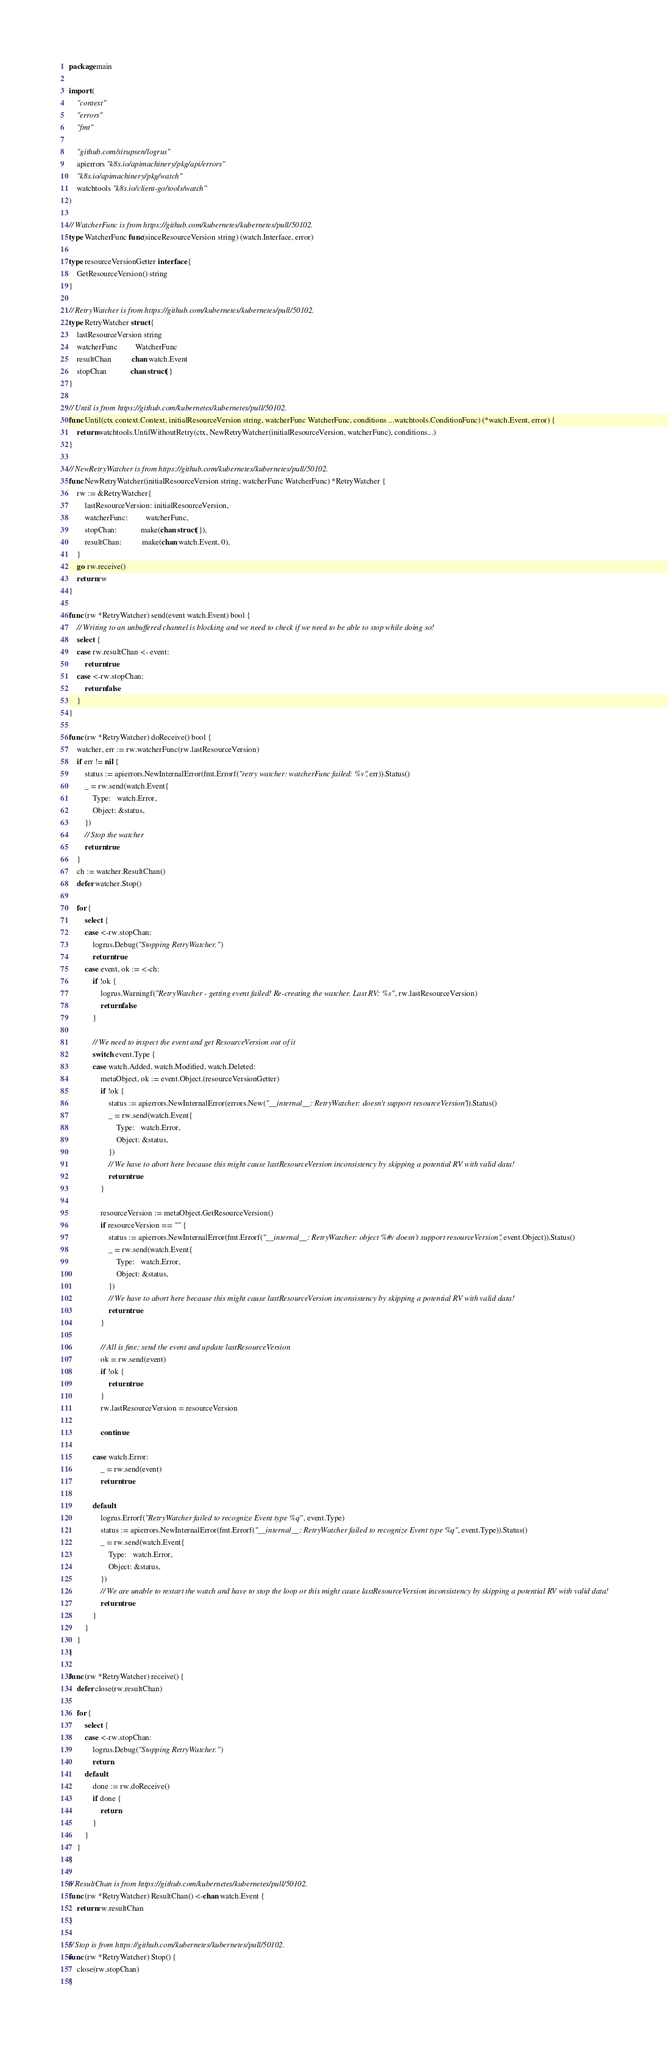Convert code to text. <code><loc_0><loc_0><loc_500><loc_500><_Go_>package main

import (
	"context"
	"errors"
	"fmt"

	"github.com/sirupsen/logrus"
	apierrors "k8s.io/apimachinery/pkg/api/errors"
	"k8s.io/apimachinery/pkg/watch"
	watchtools "k8s.io/client-go/tools/watch"
)

// WatcherFunc is from https://github.com/kubernetes/kubernetes/pull/50102.
type WatcherFunc func(sinceResourceVersion string) (watch.Interface, error)

type resourceVersionGetter interface {
	GetResourceVersion() string
}

// RetryWatcher is from https://github.com/kubernetes/kubernetes/pull/50102.
type RetryWatcher struct {
	lastResourceVersion string
	watcherFunc         WatcherFunc
	resultChan          chan watch.Event
	stopChan            chan struct{}
}

// Until is from https://github.com/kubernetes/kubernetes/pull/50102.
func Until(ctx context.Context, initialResourceVersion string, watcherFunc WatcherFunc, conditions ...watchtools.ConditionFunc) (*watch.Event, error) {
	return watchtools.UntilWithoutRetry(ctx, NewRetryWatcher(initialResourceVersion, watcherFunc), conditions...)
}

// NewRetryWatcher is from https://github.com/kubernetes/kubernetes/pull/50102.
func NewRetryWatcher(initialResourceVersion string, watcherFunc WatcherFunc) *RetryWatcher {
	rw := &RetryWatcher{
		lastResourceVersion: initialResourceVersion,
		watcherFunc:         watcherFunc,
		stopChan:            make(chan struct{}),
		resultChan:          make(chan watch.Event, 0),
	}
	go rw.receive()
	return rw
}

func (rw *RetryWatcher) send(event watch.Event) bool {
	// Writing to an unbuffered channel is blocking and we need to check if we need to be able to stop while doing so!
	select {
	case rw.resultChan <- event:
		return true
	case <-rw.stopChan:
		return false
	}
}

func (rw *RetryWatcher) doReceive() bool {
	watcher, err := rw.watcherFunc(rw.lastResourceVersion)
	if err != nil {
		status := apierrors.NewInternalError(fmt.Errorf("retry watcher: watcherFunc failed: %v", err)).Status()
		_ = rw.send(watch.Event{
			Type:   watch.Error,
			Object: &status,
		})
		// Stop the watcher
		return true
	}
	ch := watcher.ResultChan()
	defer watcher.Stop()

	for {
		select {
		case <-rw.stopChan:
			logrus.Debug("Stopping RetryWatcher.")
			return true
		case event, ok := <-ch:
			if !ok {
				logrus.Warningf("RetryWatcher - getting event failed! Re-creating the watcher. Last RV: %s", rw.lastResourceVersion)
				return false
			}

			// We need to inspect the event and get ResourceVersion out of it
			switch event.Type {
			case watch.Added, watch.Modified, watch.Deleted:
				metaObject, ok := event.Object.(resourceVersionGetter)
				if !ok {
					status := apierrors.NewInternalError(errors.New("__internal__: RetryWatcher: doesn't support resourceVersion")).Status()
					_ = rw.send(watch.Event{
						Type:   watch.Error,
						Object: &status,
					})
					// We have to abort here because this might cause lastResourceVersion inconsistency by skipping a potential RV with valid data!
					return true
				}

				resourceVersion := metaObject.GetResourceVersion()
				if resourceVersion == "" {
					status := apierrors.NewInternalError(fmt.Errorf("__internal__: RetryWatcher: object %#v doesn't support resourceVersion", event.Object)).Status()
					_ = rw.send(watch.Event{
						Type:   watch.Error,
						Object: &status,
					})
					// We have to abort here because this might cause lastResourceVersion inconsistency by skipping a potential RV with valid data!
					return true
				}

				// All is fine; send the event and update lastResourceVersion
				ok = rw.send(event)
				if !ok {
					return true
				}
				rw.lastResourceVersion = resourceVersion

				continue

			case watch.Error:
				_ = rw.send(event)
				return true

			default:
				logrus.Errorf("RetryWatcher failed to recognize Event type %q", event.Type)
				status := apierrors.NewInternalError(fmt.Errorf("__internal__: RetryWatcher failed to recognize Event type %q", event.Type)).Status()
				_ = rw.send(watch.Event{
					Type:   watch.Error,
					Object: &status,
				})
				// We are unable to restart the watch and have to stop the loop or this might cause lastResourceVersion inconsistency by skipping a potential RV with valid data!
				return true
			}
		}
	}
}

func (rw *RetryWatcher) receive() {
	defer close(rw.resultChan)

	for {
		select {
		case <-rw.stopChan:
			logrus.Debug("Stopping RetryWatcher.")
			return
		default:
			done := rw.doReceive()
			if done {
				return
			}
		}
	}
}

// ResultChan is from https://github.com/kubernetes/kubernetes/pull/50102.
func (rw *RetryWatcher) ResultChan() <-chan watch.Event {
	return rw.resultChan
}

// Stop is from https://github.com/kubernetes/kubernetes/pull/50102.
func (rw *RetryWatcher) Stop() {
	close(rw.stopChan)
}
</code> 